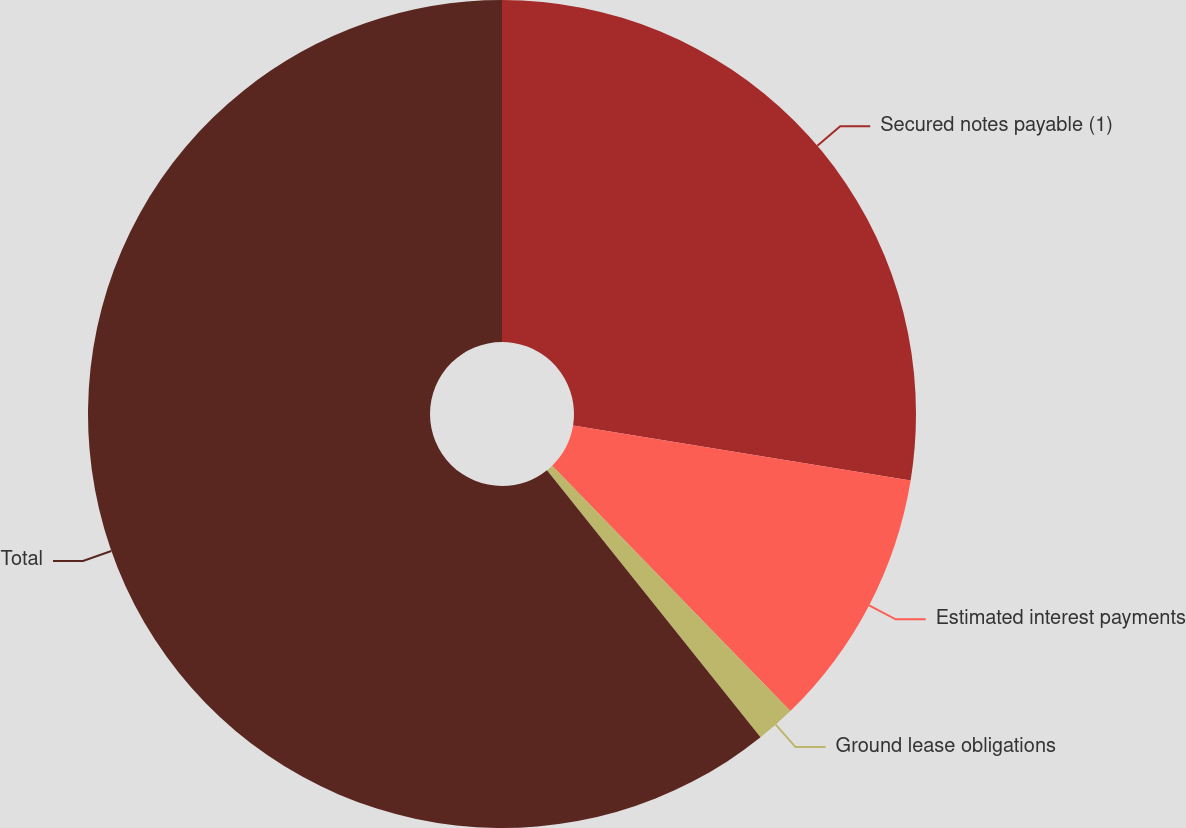Convert chart to OTSL. <chart><loc_0><loc_0><loc_500><loc_500><pie_chart><fcel>Secured notes payable (1)<fcel>Estimated interest payments<fcel>Ground lease obligations<fcel>Total<nl><fcel>27.57%<fcel>10.17%<fcel>1.53%<fcel>60.74%<nl></chart> 